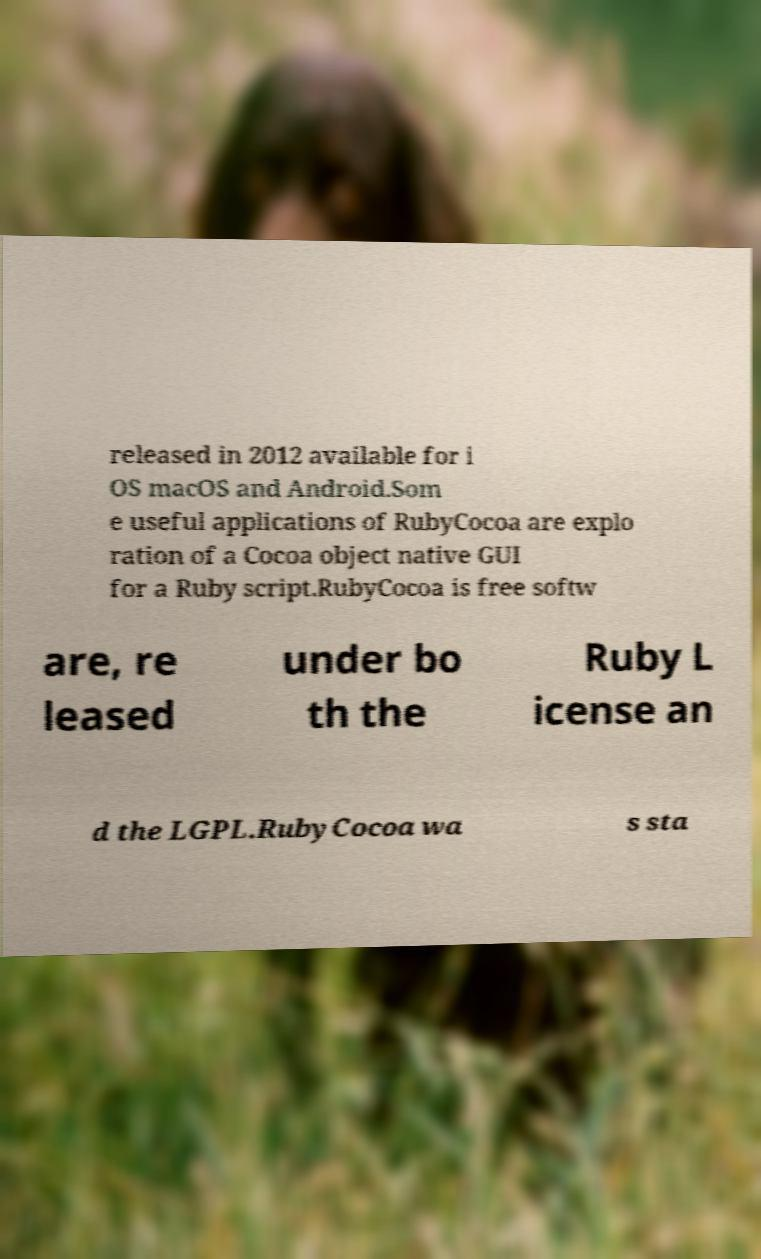I need the written content from this picture converted into text. Can you do that? released in 2012 available for i OS macOS and Android.Som e useful applications of RubyCocoa are explo ration of a Cocoa object native GUI for a Ruby script.RubyCocoa is free softw are, re leased under bo th the Ruby L icense an d the LGPL.RubyCocoa wa s sta 